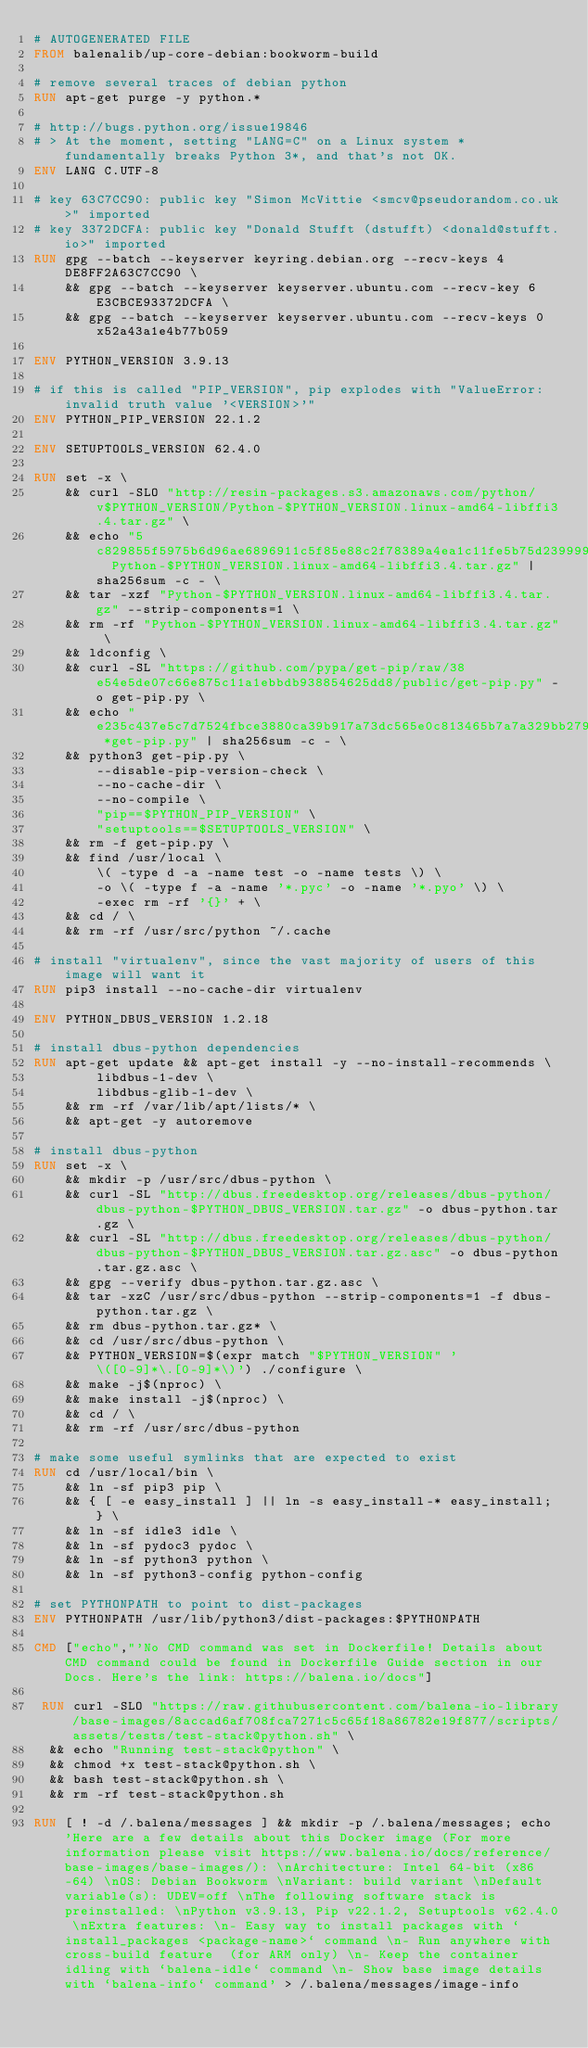Convert code to text. <code><loc_0><loc_0><loc_500><loc_500><_Dockerfile_># AUTOGENERATED FILE
FROM balenalib/up-core-debian:bookworm-build

# remove several traces of debian python
RUN apt-get purge -y python.*

# http://bugs.python.org/issue19846
# > At the moment, setting "LANG=C" on a Linux system *fundamentally breaks Python 3*, and that's not OK.
ENV LANG C.UTF-8

# key 63C7CC90: public key "Simon McVittie <smcv@pseudorandom.co.uk>" imported
# key 3372DCFA: public key "Donald Stufft (dstufft) <donald@stufft.io>" imported
RUN gpg --batch --keyserver keyring.debian.org --recv-keys 4DE8FF2A63C7CC90 \
    && gpg --batch --keyserver keyserver.ubuntu.com --recv-key 6E3CBCE93372DCFA \
    && gpg --batch --keyserver keyserver.ubuntu.com --recv-keys 0x52a43a1e4b77b059

ENV PYTHON_VERSION 3.9.13

# if this is called "PIP_VERSION", pip explodes with "ValueError: invalid truth value '<VERSION>'"
ENV PYTHON_PIP_VERSION 22.1.2

ENV SETUPTOOLS_VERSION 62.4.0

RUN set -x \
    && curl -SLO "http://resin-packages.s3.amazonaws.com/python/v$PYTHON_VERSION/Python-$PYTHON_VERSION.linux-amd64-libffi3.4.tar.gz" \
    && echo "5c829855f5975b6d96ae6896911c5f85e88c2f78389a4ea1c11fe5b75d239999  Python-$PYTHON_VERSION.linux-amd64-libffi3.4.tar.gz" | sha256sum -c - \
    && tar -xzf "Python-$PYTHON_VERSION.linux-amd64-libffi3.4.tar.gz" --strip-components=1 \
    && rm -rf "Python-$PYTHON_VERSION.linux-amd64-libffi3.4.tar.gz" \
    && ldconfig \
    && curl -SL "https://github.com/pypa/get-pip/raw/38e54e5de07c66e875c11a1ebbdb938854625dd8/public/get-pip.py" -o get-pip.py \
    && echo "e235c437e5c7d7524fbce3880ca39b917a73dc565e0c813465b7a7a329bb279a *get-pip.py" | sha256sum -c - \
    && python3 get-pip.py \
        --disable-pip-version-check \
        --no-cache-dir \
        --no-compile \
        "pip==$PYTHON_PIP_VERSION" \
        "setuptools==$SETUPTOOLS_VERSION" \
    && rm -f get-pip.py \
    && find /usr/local \
        \( -type d -a -name test -o -name tests \) \
        -o \( -type f -a -name '*.pyc' -o -name '*.pyo' \) \
        -exec rm -rf '{}' + \
    && cd / \
    && rm -rf /usr/src/python ~/.cache

# install "virtualenv", since the vast majority of users of this image will want it
RUN pip3 install --no-cache-dir virtualenv

ENV PYTHON_DBUS_VERSION 1.2.18

# install dbus-python dependencies 
RUN apt-get update && apt-get install -y --no-install-recommends \
		libdbus-1-dev \
		libdbus-glib-1-dev \
	&& rm -rf /var/lib/apt/lists/* \
	&& apt-get -y autoremove

# install dbus-python
RUN set -x \
	&& mkdir -p /usr/src/dbus-python \
	&& curl -SL "http://dbus.freedesktop.org/releases/dbus-python/dbus-python-$PYTHON_DBUS_VERSION.tar.gz" -o dbus-python.tar.gz \
	&& curl -SL "http://dbus.freedesktop.org/releases/dbus-python/dbus-python-$PYTHON_DBUS_VERSION.tar.gz.asc" -o dbus-python.tar.gz.asc \
	&& gpg --verify dbus-python.tar.gz.asc \
	&& tar -xzC /usr/src/dbus-python --strip-components=1 -f dbus-python.tar.gz \
	&& rm dbus-python.tar.gz* \
	&& cd /usr/src/dbus-python \
	&& PYTHON_VERSION=$(expr match "$PYTHON_VERSION" '\([0-9]*\.[0-9]*\)') ./configure \
	&& make -j$(nproc) \
	&& make install -j$(nproc) \
	&& cd / \
	&& rm -rf /usr/src/dbus-python

# make some useful symlinks that are expected to exist
RUN cd /usr/local/bin \
	&& ln -sf pip3 pip \
	&& { [ -e easy_install ] || ln -s easy_install-* easy_install; } \
	&& ln -sf idle3 idle \
	&& ln -sf pydoc3 pydoc \
	&& ln -sf python3 python \
	&& ln -sf python3-config python-config

# set PYTHONPATH to point to dist-packages
ENV PYTHONPATH /usr/lib/python3/dist-packages:$PYTHONPATH

CMD ["echo","'No CMD command was set in Dockerfile! Details about CMD command could be found in Dockerfile Guide section in our Docs. Here's the link: https://balena.io/docs"]

 RUN curl -SLO "https://raw.githubusercontent.com/balena-io-library/base-images/8accad6af708fca7271c5c65f18a86782e19f877/scripts/assets/tests/test-stack@python.sh" \
  && echo "Running test-stack@python" \
  && chmod +x test-stack@python.sh \
  && bash test-stack@python.sh \
  && rm -rf test-stack@python.sh 

RUN [ ! -d /.balena/messages ] && mkdir -p /.balena/messages; echo 'Here are a few details about this Docker image (For more information please visit https://www.balena.io/docs/reference/base-images/base-images/): \nArchitecture: Intel 64-bit (x86-64) \nOS: Debian Bookworm \nVariant: build variant \nDefault variable(s): UDEV=off \nThe following software stack is preinstalled: \nPython v3.9.13, Pip v22.1.2, Setuptools v62.4.0 \nExtra features: \n- Easy way to install packages with `install_packages <package-name>` command \n- Run anywhere with cross-build feature  (for ARM only) \n- Keep the container idling with `balena-idle` command \n- Show base image details with `balena-info` command' > /.balena/messages/image-info</code> 